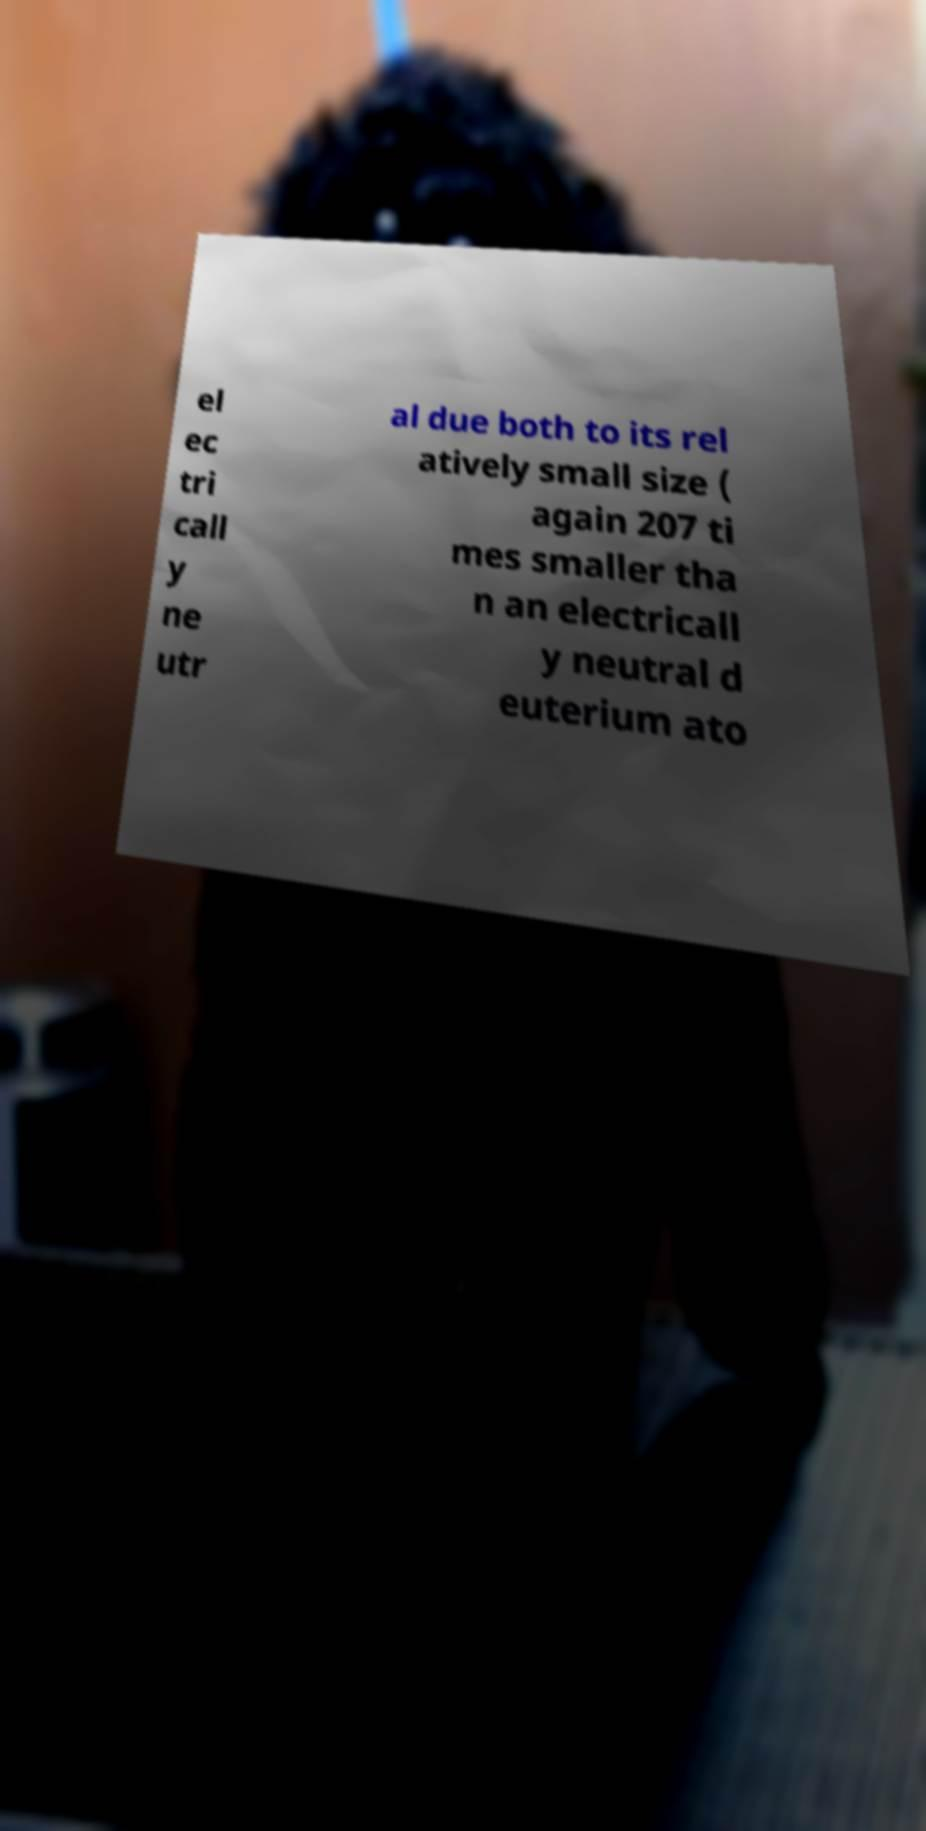Please read and relay the text visible in this image. What does it say? el ec tri call y ne utr al due both to its rel atively small size ( again 207 ti mes smaller tha n an electricall y neutral d euterium ato 